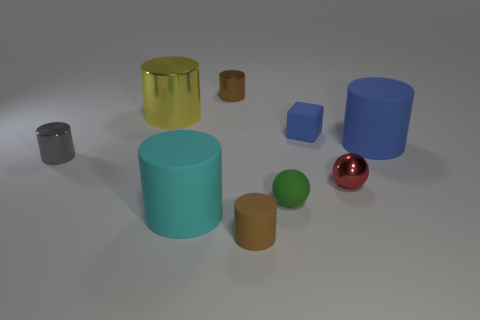Subtract 1 cylinders. How many cylinders are left? 5 Subtract all yellow cylinders. How many cylinders are left? 5 Subtract all big blue rubber cylinders. How many cylinders are left? 5 Subtract all green cylinders. Subtract all green spheres. How many cylinders are left? 6 Subtract all cubes. How many objects are left? 8 Subtract all tiny cyan objects. Subtract all blue matte objects. How many objects are left? 7 Add 7 red spheres. How many red spheres are left? 8 Add 7 purple matte balls. How many purple matte balls exist? 7 Subtract 1 yellow cylinders. How many objects are left? 8 